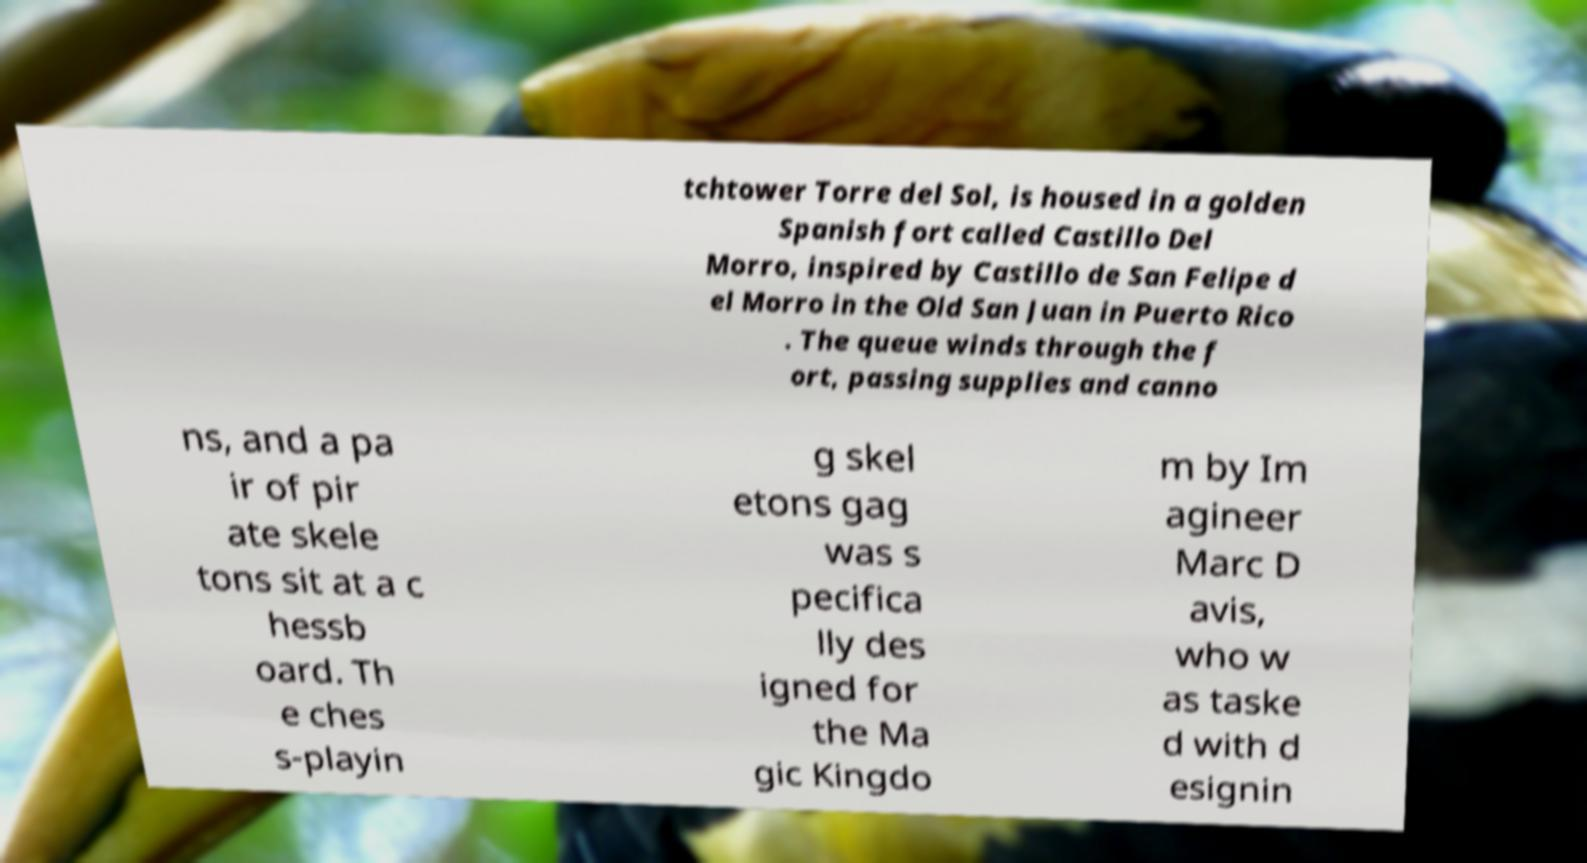Could you assist in decoding the text presented in this image and type it out clearly? tchtower Torre del Sol, is housed in a golden Spanish fort called Castillo Del Morro, inspired by Castillo de San Felipe d el Morro in the Old San Juan in Puerto Rico . The queue winds through the f ort, passing supplies and canno ns, and a pa ir of pir ate skele tons sit at a c hessb oard. Th e ches s-playin g skel etons gag was s pecifica lly des igned for the Ma gic Kingdo m by Im agineer Marc D avis, who w as taske d with d esignin 